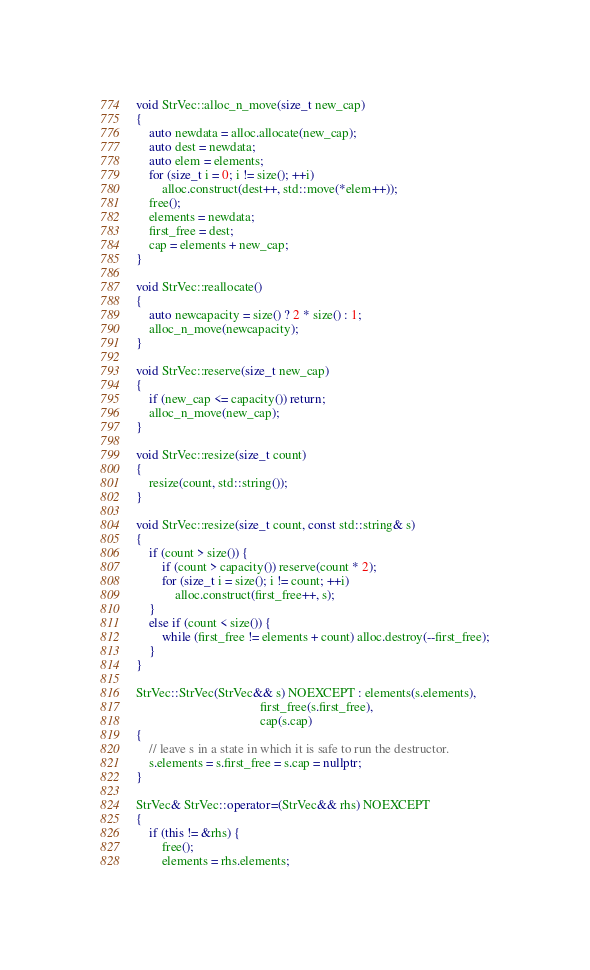Convert code to text. <code><loc_0><loc_0><loc_500><loc_500><_C++_>void StrVec::alloc_n_move(size_t new_cap)
{
    auto newdata = alloc.allocate(new_cap);
    auto dest = newdata;
    auto elem = elements;
    for (size_t i = 0; i != size(); ++i)
        alloc.construct(dest++, std::move(*elem++));
    free();
    elements = newdata;
    first_free = dest;
    cap = elements + new_cap;
}

void StrVec::reallocate()
{
    auto newcapacity = size() ? 2 * size() : 1;
    alloc_n_move(newcapacity);
}

void StrVec::reserve(size_t new_cap)
{
    if (new_cap <= capacity()) return;
    alloc_n_move(new_cap);
}

void StrVec::resize(size_t count)
{
    resize(count, std::string());
}

void StrVec::resize(size_t count, const std::string& s)
{
    if (count > size()) {
        if (count > capacity()) reserve(count * 2);
        for (size_t i = size(); i != count; ++i)
            alloc.construct(first_free++, s);
    }
    else if (count < size()) {
        while (first_free != elements + count) alloc.destroy(--first_free);
    }
}

StrVec::StrVec(StrVec&& s) NOEXCEPT : elements(s.elements),
                                      first_free(s.first_free),
                                      cap(s.cap)
{
    // leave s in a state in which it is safe to run the destructor.
    s.elements = s.first_free = s.cap = nullptr;
}

StrVec& StrVec::operator=(StrVec&& rhs) NOEXCEPT
{
    if (this != &rhs) {
        free();
        elements = rhs.elements;</code> 